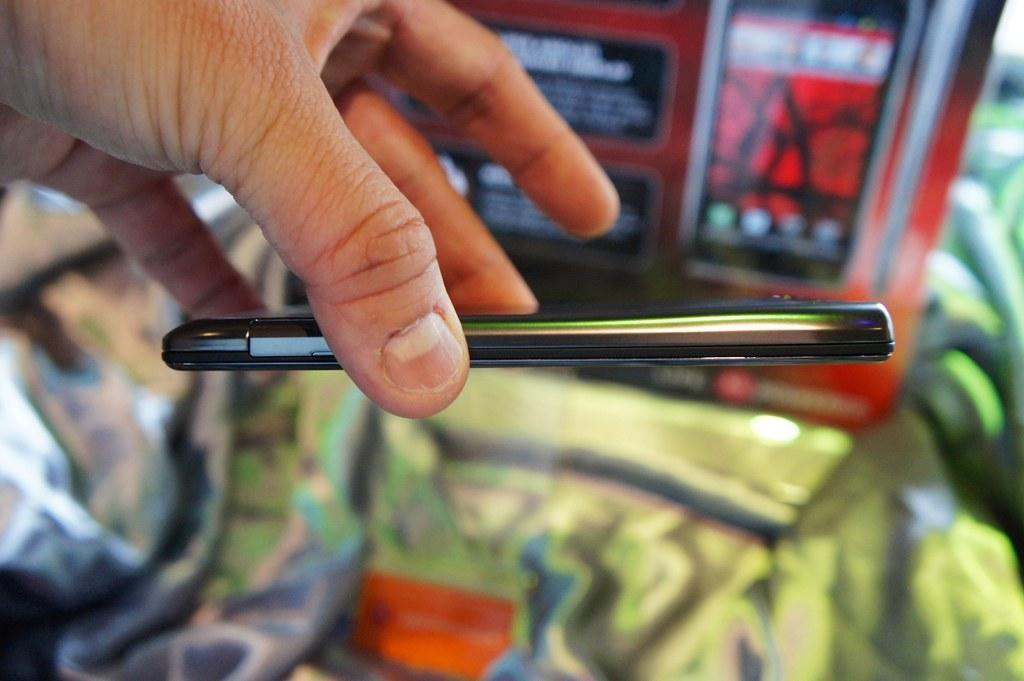What part of a person can be seen in the image? There is a person's hand in the image. What object is visible in the image? There is a mobile in the image. How would you describe the background of the image? The background of the image is blurry. Can you describe any other objects or features in the background of the image? There are unspecified objects in the background of the image. How many bears are visible in the image? There are no bears present in the image. 